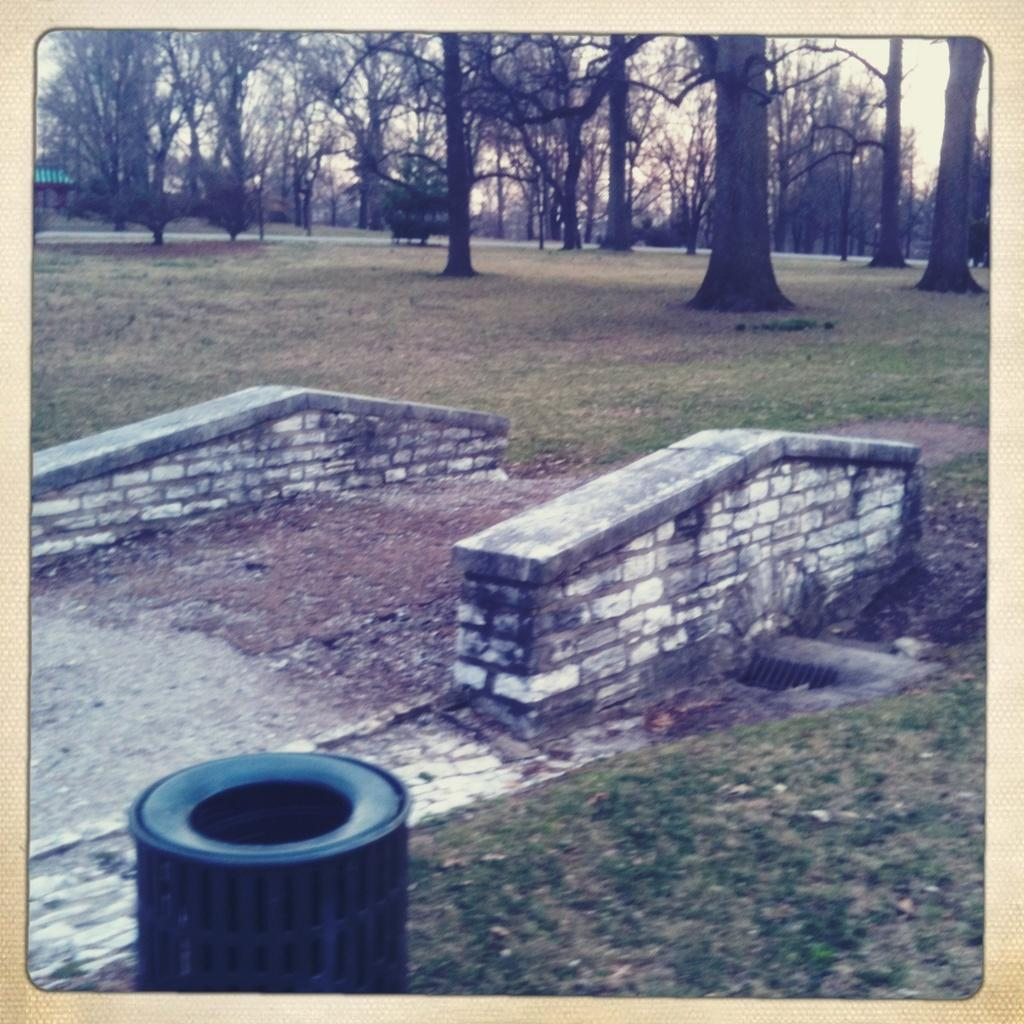What object is located at the bottom of the image? There is a dustbin at the bottom of the image. What type of vegetation can be seen in the background of the image? There is grass and trees in the background of the image. How many fowls are perched on the dock in the image? There is no dock or fowls present in the image. 